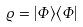Convert formula to latex. <formula><loc_0><loc_0><loc_500><loc_500>\varrho = | \Phi \rangle \langle \Phi |</formula> 